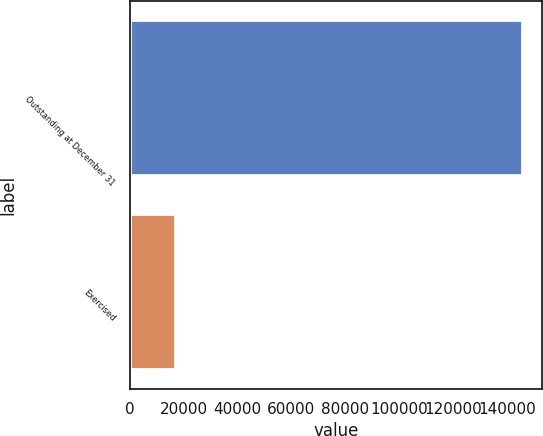Convert chart to OTSL. <chart><loc_0><loc_0><loc_500><loc_500><bar_chart><fcel>Outstanding at December 31<fcel>Exercised<nl><fcel>145751<fcel>16919<nl></chart> 